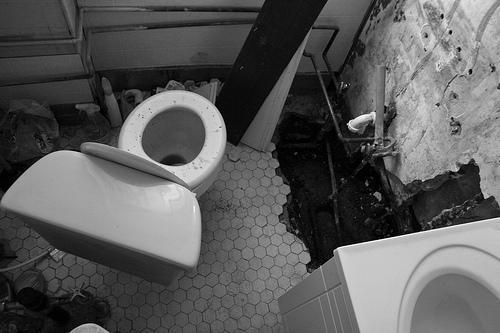How many toilets are in the photo?
Give a very brief answer. 1. 